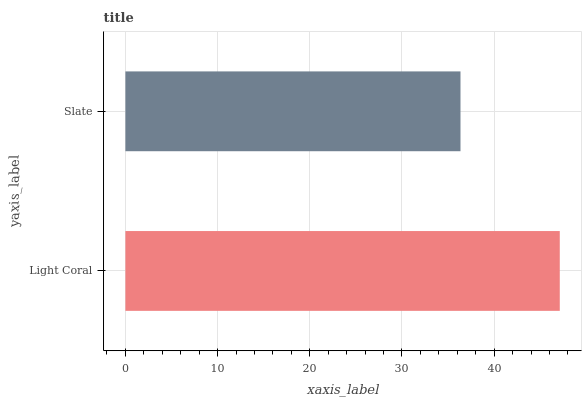Is Slate the minimum?
Answer yes or no. Yes. Is Light Coral the maximum?
Answer yes or no. Yes. Is Slate the maximum?
Answer yes or no. No. Is Light Coral greater than Slate?
Answer yes or no. Yes. Is Slate less than Light Coral?
Answer yes or no. Yes. Is Slate greater than Light Coral?
Answer yes or no. No. Is Light Coral less than Slate?
Answer yes or no. No. Is Light Coral the high median?
Answer yes or no. Yes. Is Slate the low median?
Answer yes or no. Yes. Is Slate the high median?
Answer yes or no. No. Is Light Coral the low median?
Answer yes or no. No. 